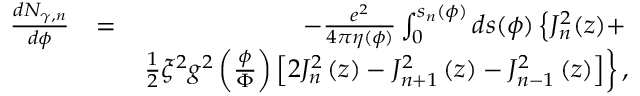<formula> <loc_0><loc_0><loc_500><loc_500>\begin{array} { r l r } { \frac { d N _ { \gamma , n } } { d \phi } } & { = } & { - \frac { e ^ { 2 } } { 4 \pi \eta ( \phi ) } \int _ { 0 } ^ { s _ { n } ( \phi ) } d s ( \phi ) \left \{ J _ { n } ^ { 2 } ( z ) + } \\ & { \frac { 1 } { 2 } \xi ^ { 2 } g ^ { 2 } \left ( \frac { \phi } { \Phi } \right ) \left [ 2 J _ { n } ^ { 2 } \left ( z \right ) - J _ { n + 1 } ^ { 2 } \left ( z \right ) - J _ { n - 1 } ^ { 2 } \left ( z \right ) \right ] \right \} , } \end{array}</formula> 